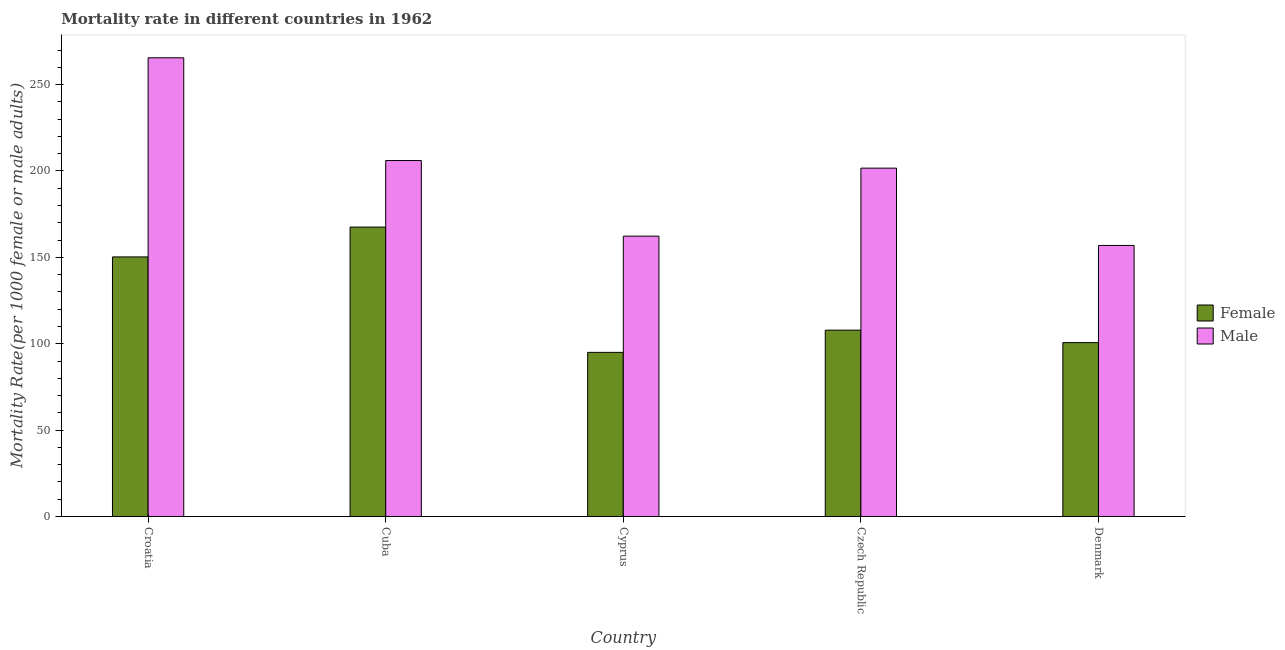Are the number of bars on each tick of the X-axis equal?
Offer a terse response. Yes. What is the label of the 3rd group of bars from the left?
Keep it short and to the point. Cyprus. What is the male mortality rate in Cuba?
Your answer should be very brief. 206.05. Across all countries, what is the maximum female mortality rate?
Your answer should be compact. 167.52. Across all countries, what is the minimum male mortality rate?
Offer a very short reply. 156.9. In which country was the male mortality rate maximum?
Your answer should be compact. Croatia. In which country was the female mortality rate minimum?
Make the answer very short. Cyprus. What is the total male mortality rate in the graph?
Keep it short and to the point. 992.39. What is the difference between the male mortality rate in Croatia and that in Cyprus?
Give a very brief answer. 103.23. What is the difference between the female mortality rate in Cuba and the male mortality rate in Cyprus?
Offer a very short reply. 5.24. What is the average female mortality rate per country?
Provide a short and direct response. 124.26. What is the difference between the male mortality rate and female mortality rate in Cyprus?
Provide a short and direct response. 67.28. What is the ratio of the male mortality rate in Croatia to that in Denmark?
Offer a terse response. 1.69. What is the difference between the highest and the second highest male mortality rate?
Your answer should be very brief. 59.47. What is the difference between the highest and the lowest male mortality rate?
Your answer should be compact. 108.62. In how many countries, is the female mortality rate greater than the average female mortality rate taken over all countries?
Make the answer very short. 2. Is the sum of the female mortality rate in Cyprus and Denmark greater than the maximum male mortality rate across all countries?
Give a very brief answer. No. What does the 1st bar from the left in Czech Republic represents?
Give a very brief answer. Female. What does the 1st bar from the right in Czech Republic represents?
Your answer should be very brief. Male. How many bars are there?
Make the answer very short. 10. How many countries are there in the graph?
Offer a terse response. 5. What is the difference between two consecutive major ticks on the Y-axis?
Ensure brevity in your answer.  50. Are the values on the major ticks of Y-axis written in scientific E-notation?
Give a very brief answer. No. Does the graph contain any zero values?
Provide a succinct answer. No. How many legend labels are there?
Keep it short and to the point. 2. How are the legend labels stacked?
Offer a terse response. Vertical. What is the title of the graph?
Keep it short and to the point. Mortality rate in different countries in 1962. What is the label or title of the X-axis?
Keep it short and to the point. Country. What is the label or title of the Y-axis?
Give a very brief answer. Mortality Rate(per 1000 female or male adults). What is the Mortality Rate(per 1000 female or male adults) in Female in Croatia?
Your answer should be very brief. 150.26. What is the Mortality Rate(per 1000 female or male adults) of Male in Croatia?
Keep it short and to the point. 265.52. What is the Mortality Rate(per 1000 female or male adults) of Female in Cuba?
Your response must be concise. 167.52. What is the Mortality Rate(per 1000 female or male adults) of Male in Cuba?
Make the answer very short. 206.05. What is the Mortality Rate(per 1000 female or male adults) in Female in Cyprus?
Provide a short and direct response. 95. What is the Mortality Rate(per 1000 female or male adults) of Male in Cyprus?
Provide a short and direct response. 162.28. What is the Mortality Rate(per 1000 female or male adults) in Female in Czech Republic?
Your response must be concise. 107.87. What is the Mortality Rate(per 1000 female or male adults) in Male in Czech Republic?
Your answer should be very brief. 201.65. What is the Mortality Rate(per 1000 female or male adults) of Female in Denmark?
Keep it short and to the point. 100.66. What is the Mortality Rate(per 1000 female or male adults) of Male in Denmark?
Offer a terse response. 156.9. Across all countries, what is the maximum Mortality Rate(per 1000 female or male adults) in Female?
Your answer should be very brief. 167.52. Across all countries, what is the maximum Mortality Rate(per 1000 female or male adults) in Male?
Make the answer very short. 265.52. Across all countries, what is the minimum Mortality Rate(per 1000 female or male adults) in Female?
Your response must be concise. 95. Across all countries, what is the minimum Mortality Rate(per 1000 female or male adults) of Male?
Your response must be concise. 156.9. What is the total Mortality Rate(per 1000 female or male adults) in Female in the graph?
Ensure brevity in your answer.  621.32. What is the total Mortality Rate(per 1000 female or male adults) in Male in the graph?
Offer a very short reply. 992.39. What is the difference between the Mortality Rate(per 1000 female or male adults) in Female in Croatia and that in Cuba?
Provide a short and direct response. -17.26. What is the difference between the Mortality Rate(per 1000 female or male adults) of Male in Croatia and that in Cuba?
Offer a terse response. 59.47. What is the difference between the Mortality Rate(per 1000 female or male adults) in Female in Croatia and that in Cyprus?
Make the answer very short. 55.26. What is the difference between the Mortality Rate(per 1000 female or male adults) in Male in Croatia and that in Cyprus?
Make the answer very short. 103.23. What is the difference between the Mortality Rate(per 1000 female or male adults) of Female in Croatia and that in Czech Republic?
Provide a short and direct response. 42.39. What is the difference between the Mortality Rate(per 1000 female or male adults) in Male in Croatia and that in Czech Republic?
Make the answer very short. 63.87. What is the difference between the Mortality Rate(per 1000 female or male adults) in Female in Croatia and that in Denmark?
Give a very brief answer. 49.6. What is the difference between the Mortality Rate(per 1000 female or male adults) in Male in Croatia and that in Denmark?
Your answer should be compact. 108.62. What is the difference between the Mortality Rate(per 1000 female or male adults) of Female in Cuba and that in Cyprus?
Keep it short and to the point. 72.52. What is the difference between the Mortality Rate(per 1000 female or male adults) in Male in Cuba and that in Cyprus?
Ensure brevity in your answer.  43.76. What is the difference between the Mortality Rate(per 1000 female or male adults) of Female in Cuba and that in Czech Republic?
Offer a terse response. 59.65. What is the difference between the Mortality Rate(per 1000 female or male adults) in Male in Cuba and that in Czech Republic?
Provide a short and direct response. 4.4. What is the difference between the Mortality Rate(per 1000 female or male adults) of Female in Cuba and that in Denmark?
Make the answer very short. 66.86. What is the difference between the Mortality Rate(per 1000 female or male adults) in Male in Cuba and that in Denmark?
Your answer should be compact. 49.15. What is the difference between the Mortality Rate(per 1000 female or male adults) of Female in Cyprus and that in Czech Republic?
Offer a very short reply. -12.87. What is the difference between the Mortality Rate(per 1000 female or male adults) in Male in Cyprus and that in Czech Republic?
Offer a very short reply. -39.37. What is the difference between the Mortality Rate(per 1000 female or male adults) of Female in Cyprus and that in Denmark?
Your answer should be compact. -5.66. What is the difference between the Mortality Rate(per 1000 female or male adults) of Male in Cyprus and that in Denmark?
Offer a very short reply. 5.39. What is the difference between the Mortality Rate(per 1000 female or male adults) of Female in Czech Republic and that in Denmark?
Your answer should be very brief. 7.21. What is the difference between the Mortality Rate(per 1000 female or male adults) of Male in Czech Republic and that in Denmark?
Make the answer very short. 44.75. What is the difference between the Mortality Rate(per 1000 female or male adults) of Female in Croatia and the Mortality Rate(per 1000 female or male adults) of Male in Cuba?
Provide a short and direct response. -55.78. What is the difference between the Mortality Rate(per 1000 female or male adults) of Female in Croatia and the Mortality Rate(per 1000 female or male adults) of Male in Cyprus?
Provide a short and direct response. -12.02. What is the difference between the Mortality Rate(per 1000 female or male adults) in Female in Croatia and the Mortality Rate(per 1000 female or male adults) in Male in Czech Republic?
Ensure brevity in your answer.  -51.39. What is the difference between the Mortality Rate(per 1000 female or male adults) of Female in Croatia and the Mortality Rate(per 1000 female or male adults) of Male in Denmark?
Make the answer very short. -6.63. What is the difference between the Mortality Rate(per 1000 female or male adults) in Female in Cuba and the Mortality Rate(per 1000 female or male adults) in Male in Cyprus?
Offer a very short reply. 5.24. What is the difference between the Mortality Rate(per 1000 female or male adults) of Female in Cuba and the Mortality Rate(per 1000 female or male adults) of Male in Czech Republic?
Give a very brief answer. -34.13. What is the difference between the Mortality Rate(per 1000 female or male adults) in Female in Cuba and the Mortality Rate(per 1000 female or male adults) in Male in Denmark?
Offer a very short reply. 10.62. What is the difference between the Mortality Rate(per 1000 female or male adults) of Female in Cyprus and the Mortality Rate(per 1000 female or male adults) of Male in Czech Republic?
Your answer should be very brief. -106.65. What is the difference between the Mortality Rate(per 1000 female or male adults) in Female in Cyprus and the Mortality Rate(per 1000 female or male adults) in Male in Denmark?
Make the answer very short. -61.89. What is the difference between the Mortality Rate(per 1000 female or male adults) of Female in Czech Republic and the Mortality Rate(per 1000 female or male adults) of Male in Denmark?
Ensure brevity in your answer.  -49.03. What is the average Mortality Rate(per 1000 female or male adults) of Female per country?
Make the answer very short. 124.26. What is the average Mortality Rate(per 1000 female or male adults) of Male per country?
Your answer should be very brief. 198.48. What is the difference between the Mortality Rate(per 1000 female or male adults) in Female and Mortality Rate(per 1000 female or male adults) in Male in Croatia?
Your answer should be very brief. -115.25. What is the difference between the Mortality Rate(per 1000 female or male adults) in Female and Mortality Rate(per 1000 female or male adults) in Male in Cuba?
Offer a terse response. -38.52. What is the difference between the Mortality Rate(per 1000 female or male adults) in Female and Mortality Rate(per 1000 female or male adults) in Male in Cyprus?
Your answer should be very brief. -67.28. What is the difference between the Mortality Rate(per 1000 female or male adults) in Female and Mortality Rate(per 1000 female or male adults) in Male in Czech Republic?
Offer a very short reply. -93.78. What is the difference between the Mortality Rate(per 1000 female or male adults) in Female and Mortality Rate(per 1000 female or male adults) in Male in Denmark?
Offer a very short reply. -56.24. What is the ratio of the Mortality Rate(per 1000 female or male adults) of Female in Croatia to that in Cuba?
Your answer should be compact. 0.9. What is the ratio of the Mortality Rate(per 1000 female or male adults) of Male in Croatia to that in Cuba?
Give a very brief answer. 1.29. What is the ratio of the Mortality Rate(per 1000 female or male adults) of Female in Croatia to that in Cyprus?
Ensure brevity in your answer.  1.58. What is the ratio of the Mortality Rate(per 1000 female or male adults) in Male in Croatia to that in Cyprus?
Give a very brief answer. 1.64. What is the ratio of the Mortality Rate(per 1000 female or male adults) in Female in Croatia to that in Czech Republic?
Your answer should be compact. 1.39. What is the ratio of the Mortality Rate(per 1000 female or male adults) of Male in Croatia to that in Czech Republic?
Your response must be concise. 1.32. What is the ratio of the Mortality Rate(per 1000 female or male adults) in Female in Croatia to that in Denmark?
Make the answer very short. 1.49. What is the ratio of the Mortality Rate(per 1000 female or male adults) of Male in Croatia to that in Denmark?
Your answer should be very brief. 1.69. What is the ratio of the Mortality Rate(per 1000 female or male adults) in Female in Cuba to that in Cyprus?
Make the answer very short. 1.76. What is the ratio of the Mortality Rate(per 1000 female or male adults) in Male in Cuba to that in Cyprus?
Provide a short and direct response. 1.27. What is the ratio of the Mortality Rate(per 1000 female or male adults) in Female in Cuba to that in Czech Republic?
Ensure brevity in your answer.  1.55. What is the ratio of the Mortality Rate(per 1000 female or male adults) of Male in Cuba to that in Czech Republic?
Provide a short and direct response. 1.02. What is the ratio of the Mortality Rate(per 1000 female or male adults) of Female in Cuba to that in Denmark?
Ensure brevity in your answer.  1.66. What is the ratio of the Mortality Rate(per 1000 female or male adults) of Male in Cuba to that in Denmark?
Give a very brief answer. 1.31. What is the ratio of the Mortality Rate(per 1000 female or male adults) of Female in Cyprus to that in Czech Republic?
Give a very brief answer. 0.88. What is the ratio of the Mortality Rate(per 1000 female or male adults) of Male in Cyprus to that in Czech Republic?
Make the answer very short. 0.8. What is the ratio of the Mortality Rate(per 1000 female or male adults) in Female in Cyprus to that in Denmark?
Offer a terse response. 0.94. What is the ratio of the Mortality Rate(per 1000 female or male adults) of Male in Cyprus to that in Denmark?
Offer a terse response. 1.03. What is the ratio of the Mortality Rate(per 1000 female or male adults) of Female in Czech Republic to that in Denmark?
Ensure brevity in your answer.  1.07. What is the ratio of the Mortality Rate(per 1000 female or male adults) in Male in Czech Republic to that in Denmark?
Ensure brevity in your answer.  1.29. What is the difference between the highest and the second highest Mortality Rate(per 1000 female or male adults) in Female?
Keep it short and to the point. 17.26. What is the difference between the highest and the second highest Mortality Rate(per 1000 female or male adults) of Male?
Provide a succinct answer. 59.47. What is the difference between the highest and the lowest Mortality Rate(per 1000 female or male adults) of Female?
Provide a short and direct response. 72.52. What is the difference between the highest and the lowest Mortality Rate(per 1000 female or male adults) in Male?
Provide a succinct answer. 108.62. 